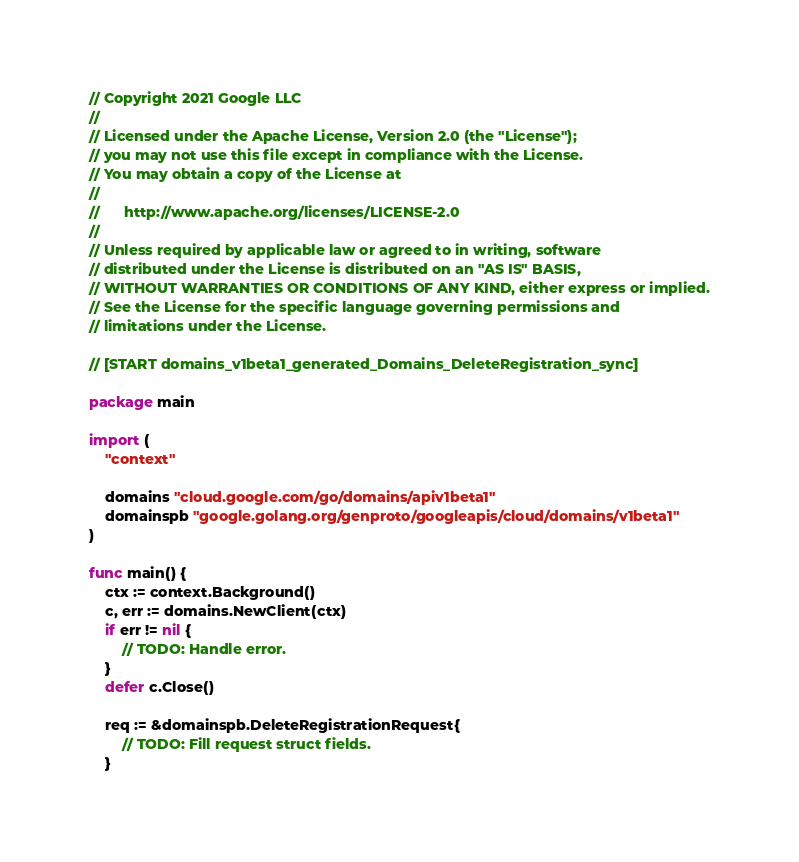Convert code to text. <code><loc_0><loc_0><loc_500><loc_500><_Go_>// Copyright 2021 Google LLC
//
// Licensed under the Apache License, Version 2.0 (the "License");
// you may not use this file except in compliance with the License.
// You may obtain a copy of the License at
//
//      http://www.apache.org/licenses/LICENSE-2.0
//
// Unless required by applicable law or agreed to in writing, software
// distributed under the License is distributed on an "AS IS" BASIS,
// WITHOUT WARRANTIES OR CONDITIONS OF ANY KIND, either express or implied.
// See the License for the specific language governing permissions and
// limitations under the License.

// [START domains_v1beta1_generated_Domains_DeleteRegistration_sync]

package main

import (
	"context"

	domains "cloud.google.com/go/domains/apiv1beta1"
	domainspb "google.golang.org/genproto/googleapis/cloud/domains/v1beta1"
)

func main() {
	ctx := context.Background()
	c, err := domains.NewClient(ctx)
	if err != nil {
		// TODO: Handle error.
	}
	defer c.Close()

	req := &domainspb.DeleteRegistrationRequest{
		// TODO: Fill request struct fields.
	}</code> 